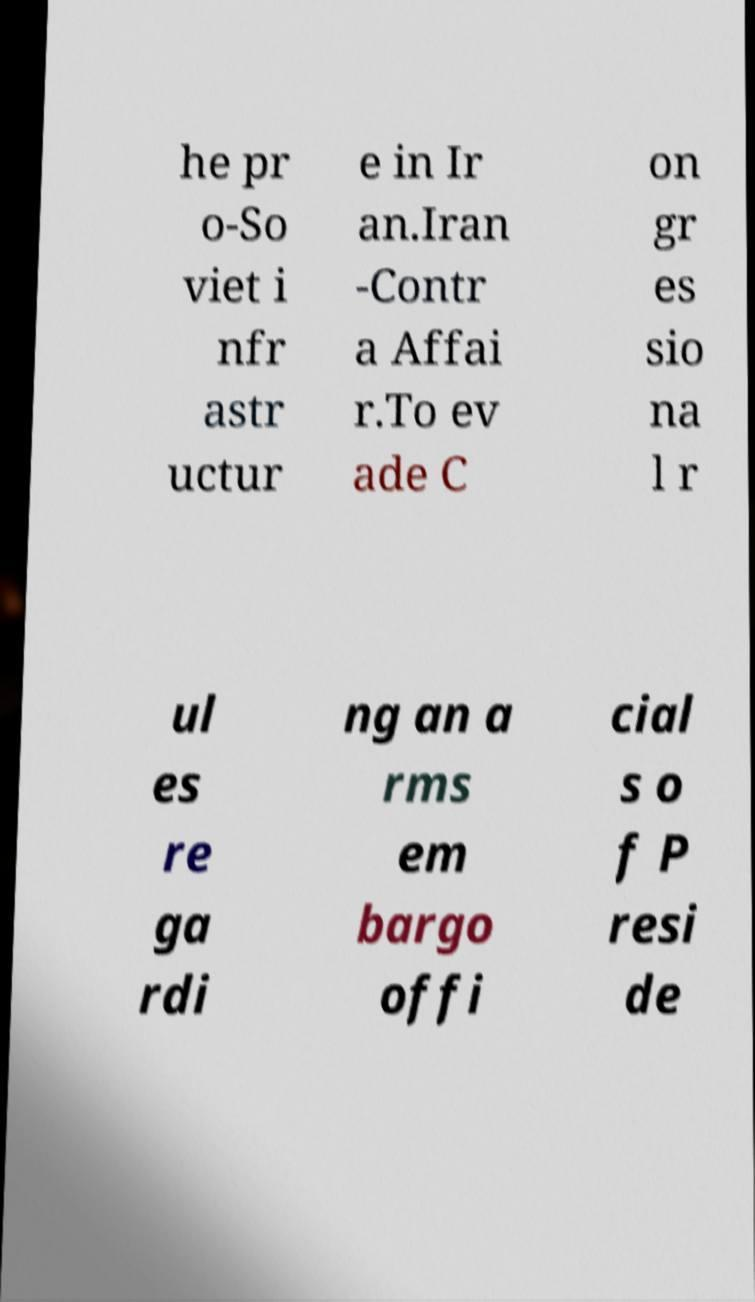What messages or text are displayed in this image? I need them in a readable, typed format. he pr o-So viet i nfr astr uctur e in Ir an.Iran -Contr a Affai r.To ev ade C on gr es sio na l r ul es re ga rdi ng an a rms em bargo offi cial s o f P resi de 